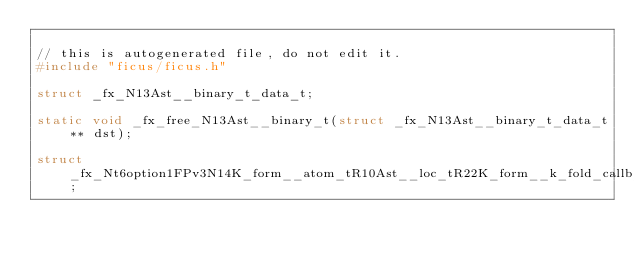Convert code to text. <code><loc_0><loc_0><loc_500><loc_500><_C_>
// this is autogenerated file, do not edit it.
#include "ficus/ficus.h"

struct _fx_N13Ast__binary_t_data_t;

static void _fx_free_N13Ast__binary_t(struct _fx_N13Ast__binary_t_data_t** dst);

struct _fx_Nt6option1FPv3N14K_form__atom_tR10Ast__loc_tR22K_form__k_fold_callb_t_data_t;
</code> 